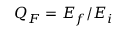Convert formula to latex. <formula><loc_0><loc_0><loc_500><loc_500>Q _ { F } = E _ { f } / E _ { i }</formula> 